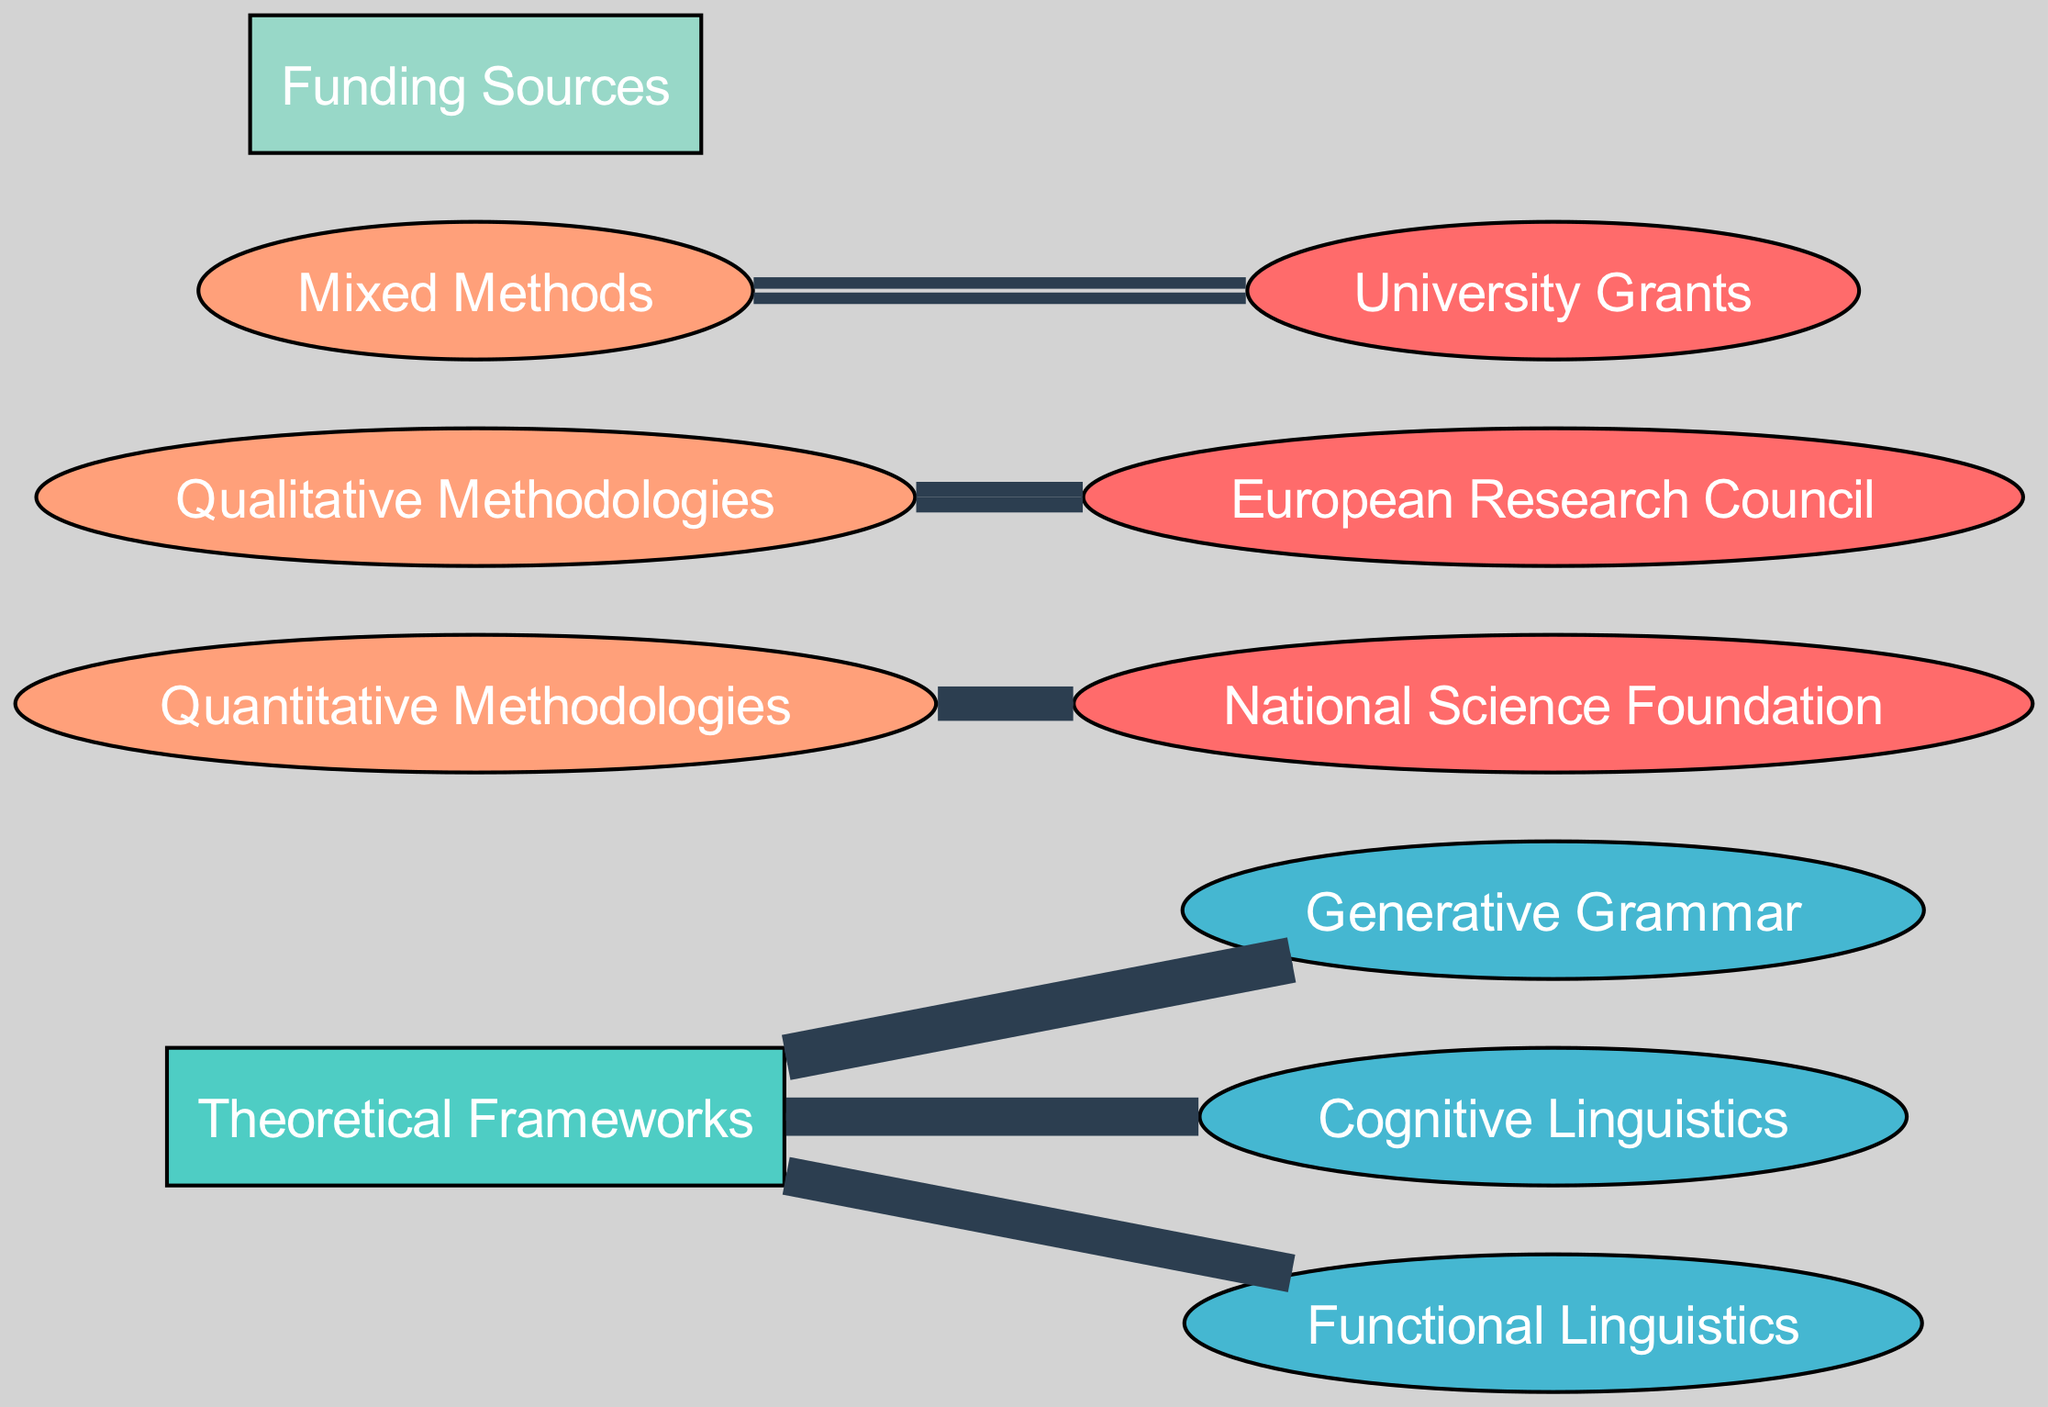What is the total funding allocated to Generative Grammar? The diagram shows an edge from "Theoretical Frameworks" to "Generative Grammar" with a value of 40, indicating that 40 units of funding are allocated to this category.
Answer: 40 Which funding source is connected to Mixed Methods? The Sankey diagram displays an edge from "Mixed Methods" to "University Grants" with a value of 15, indicating that this is the connection between these elements.
Answer: University Grants How many theoretical frameworks are represented in the diagram? By examining the nodes labeled under "Theoretical Frameworks," there are three frameworks listed: Generative Grammar, Cognitive Linguistics, and Functional Linguistics, making a total of three.
Answer: 3 Which methodology has the highest funding allocation? The values show that Quantitative Methodologies has an edge to National Science Foundation with 25, while the others have lower values. Thus, Quantitative Methodologies has the highest value, which is 25.
Answer: Quantitative Methodologies What is the total funding allocated to Qualitative Methodologies? The diagram indicates that Qualitative Methodologies is associated with the European Research Council with a funding value of 20. This is the only connection listed for this methodology.
Answer: 20 Which theoretical framework received equal funding to Functional Linguistics? The diagram represents both Cognitive Linguistics and Functional Linguistics with the same value of 30, hence Cognitive Linguistics received equal funding.
Answer: Cognitive Linguistics How many edges are connected to national science foundation? There is one edge stemming from "Quantitative Methodologies" leading to "National Science Foundation" in the diagram, showing a singular connection that pertains to this funding source.
Answer: 1 What is the total funding from all sources connected to Qualitative Methodologies? The diagram reveals that there is a single connection from Qualitative Methodologies to the European Research Council valued at 20, indicating this is the total amount from this methodology.
Answer: 20 What percentage of total funding (sum of all edges) is allocated to Cognitive Linguistics? The total funding is 40 + 30 + 30 + 25 + 20 + 15 = 160. Cognitive Linguistics receives 30 units. Thus, the percentage is (30/160)*100 = 18.75%.
Answer: 18.75% 